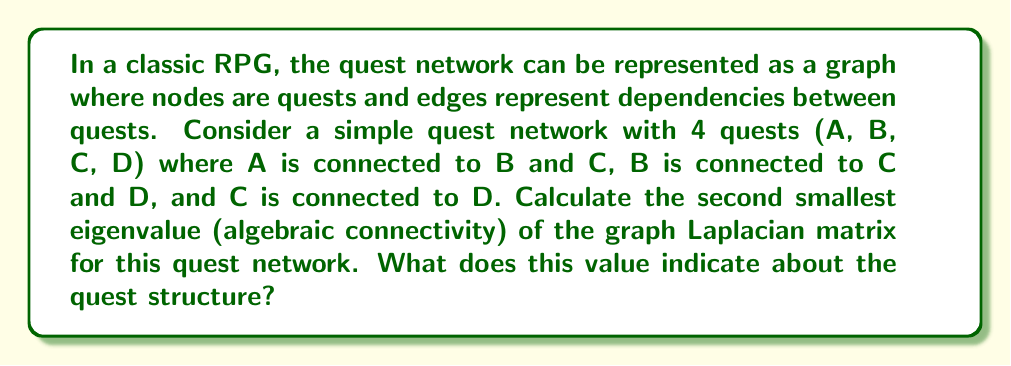Can you answer this question? Let's approach this step-by-step:

1) First, we need to construct the adjacency matrix A:
   $$A = \begin{bmatrix}
   0 & 1 & 1 & 0 \\
   1 & 0 & 1 & 1 \\
   1 & 1 & 0 & 1 \\
   0 & 1 & 1 & 0
   \end{bmatrix}$$

2) Next, we calculate the degree matrix D:
   $$D = \begin{bmatrix}
   2 & 0 & 0 & 0 \\
   0 & 3 & 0 & 0 \\
   0 & 0 & 3 & 0 \\
   0 & 0 & 0 & 2
   \end{bmatrix}$$

3) The Laplacian matrix L is given by L = D - A:
   $$L = \begin{bmatrix}
   2 & -1 & -1 & 0 \\
   -1 & 3 & -1 & -1 \\
   -1 & -1 & 3 & -1 \\
   0 & -1 & -1 & 2
   \end{bmatrix}$$

4) To find the eigenvalues, we solve the characteristic equation det(L - λI) = 0:
   $$det\begin{bmatrix}
   2-λ & -1 & -1 & 0 \\
   -1 & 3-λ & -1 & -1 \\
   -1 & -1 & 3-λ & -1 \\
   0 & -1 & -1 & 2-λ
   \end{bmatrix} = 0$$

5) Solving this equation (which can be done using computer algebra systems), we get the eigenvalues:
   λ₁ = 0, λ₂ = 1, λ₃ = 3, λ₄ = 4

6) The second smallest eigenvalue, also known as the algebraic connectivity, is λ₂ = 1.

7) This value indicates how well-connected the quest network is. A higher value suggests a more interconnected quest structure, while a lower value indicates a more linear or disconnected structure. In this case, the value of 1 suggests a moderately connected quest network, allowing for some player choice in quest order while maintaining some structure.
Answer: 1 (moderate connectivity) 